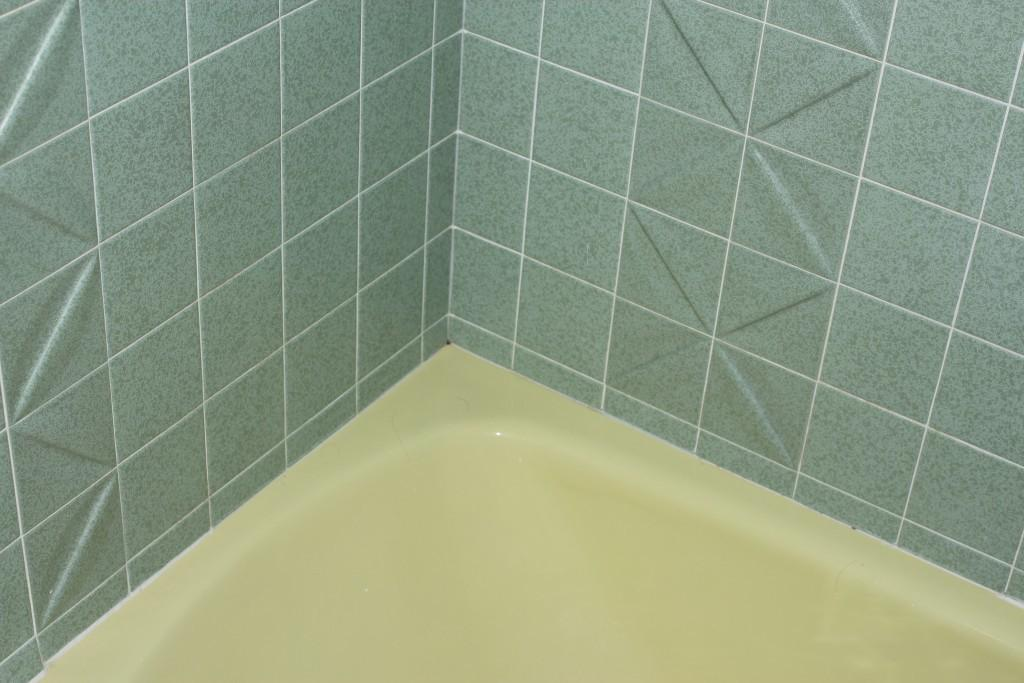What type of setting is likely depicted in the image? The image likely depicts a bathtub, which suggests a restroom setting. Can you describe any specific features of the bathtub? Unfortunately, the provided facts do not offer specific details about the bathtub. What might be present in the restroom setting along with the bathtub? While the facts do not specify any additional items, it is common to find a sink, toilet, and possibly a shower in a restroom setting. What type of locket can be seen hanging from the bathtub faucet in the image? There is no locket present in the image, as it depicts a bathtub and not a piece of jewelry. What type of fuel is being used to heat the water in the bathtub? The facts provided do not mention any fuel source for heating the water in the bathtub. 